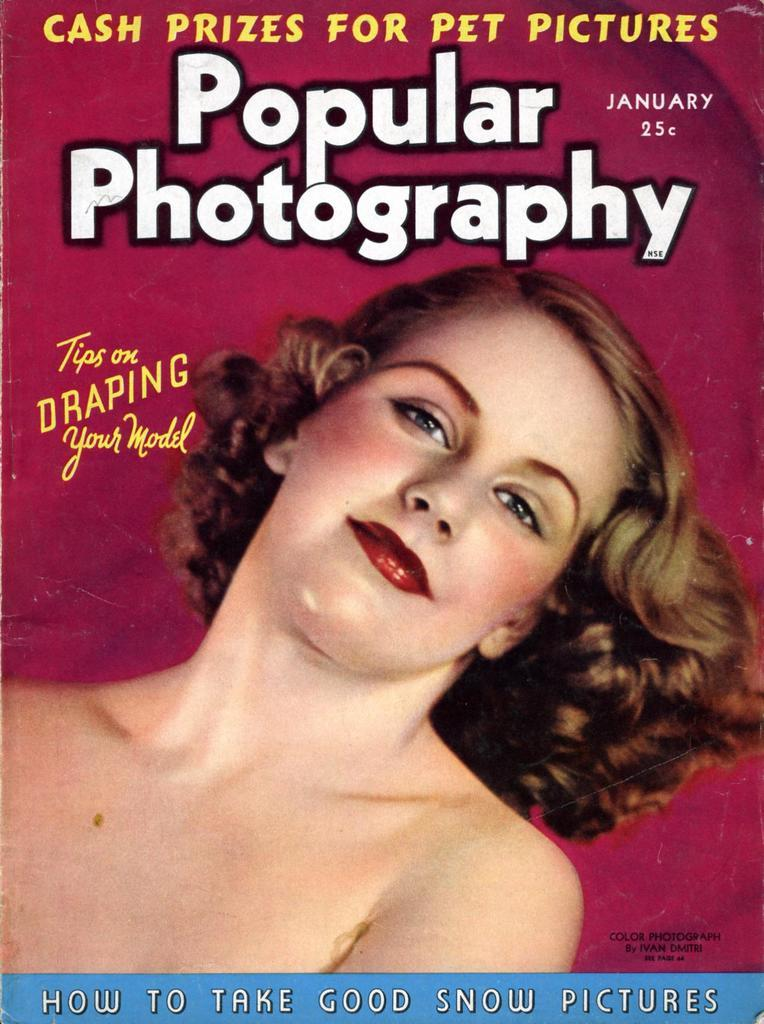What is the main subject of the image? There is a picture of a woman in the image. What else can be seen in the image besides the woman? There is text on the image. What type of meat is being prepared in the image? There is no meat or any indication of food preparation in the image. 